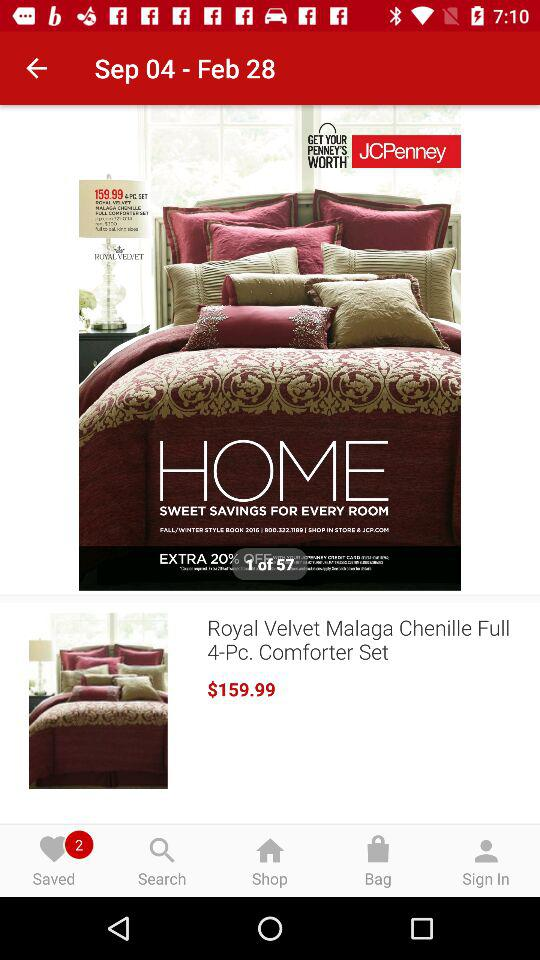How many pieces are in one set? There are 4 pieces in one set. 